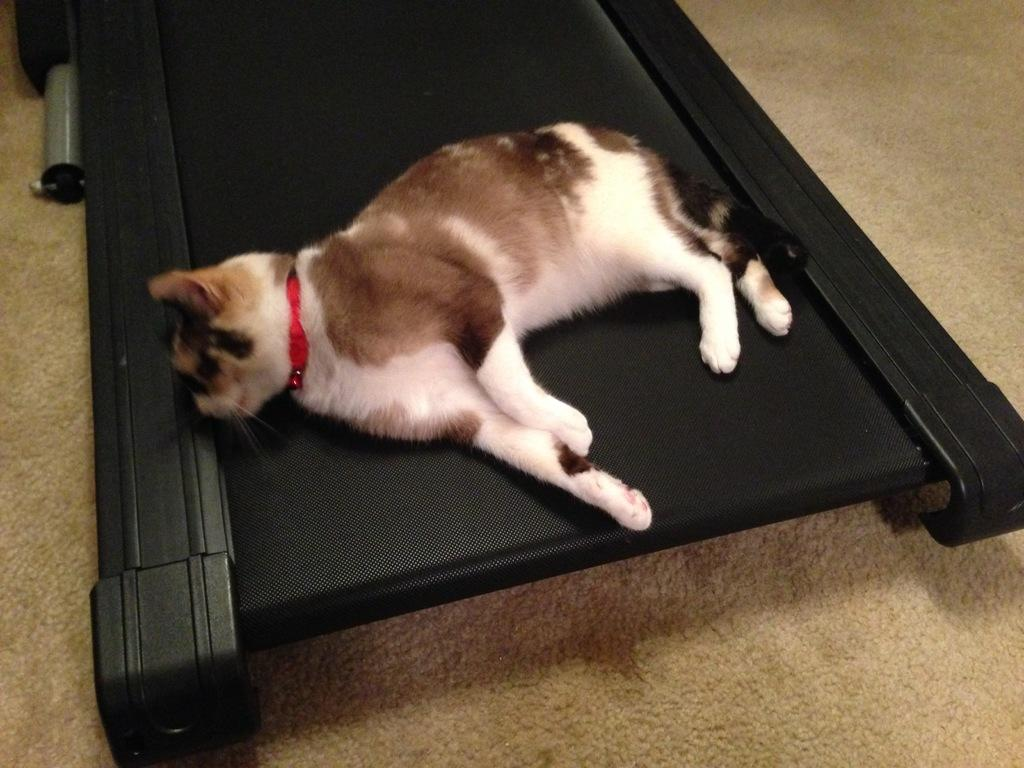What animal can be seen in the image? There is a cat in the image. What is the cat doing in the image? The cat is sleeping. Where is the cat located in the image? The cat is on a treadmill. What is around the cat's neck in the image? There is a belt around the cat's neck. What is on the floor at the bottom of the image? There is a mat on the floor at the bottom of the image. What type of argument is the cat having with the treadmill in the image? There is no argument present in the image; the cat is simply sleeping on the treadmill. 